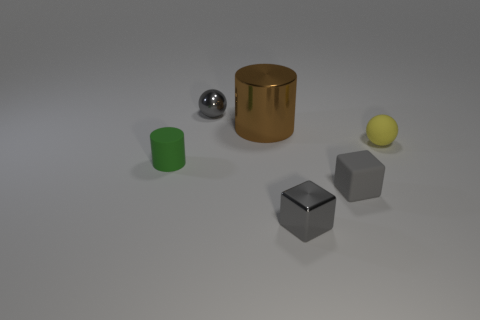Add 4 tiny metal objects. How many objects exist? 10 Subtract 1 cubes. How many cubes are left? 1 Subtract all gray spheres. How many spheres are left? 1 Subtract all cylinders. How many objects are left? 4 Subtract all yellow spheres. How many brown cylinders are left? 1 Subtract all tiny gray objects. Subtract all yellow balls. How many objects are left? 2 Add 6 big metal things. How many big metal things are left? 7 Add 2 tiny cubes. How many tiny cubes exist? 4 Subtract 0 green spheres. How many objects are left? 6 Subtract all yellow blocks. Subtract all purple spheres. How many blocks are left? 2 